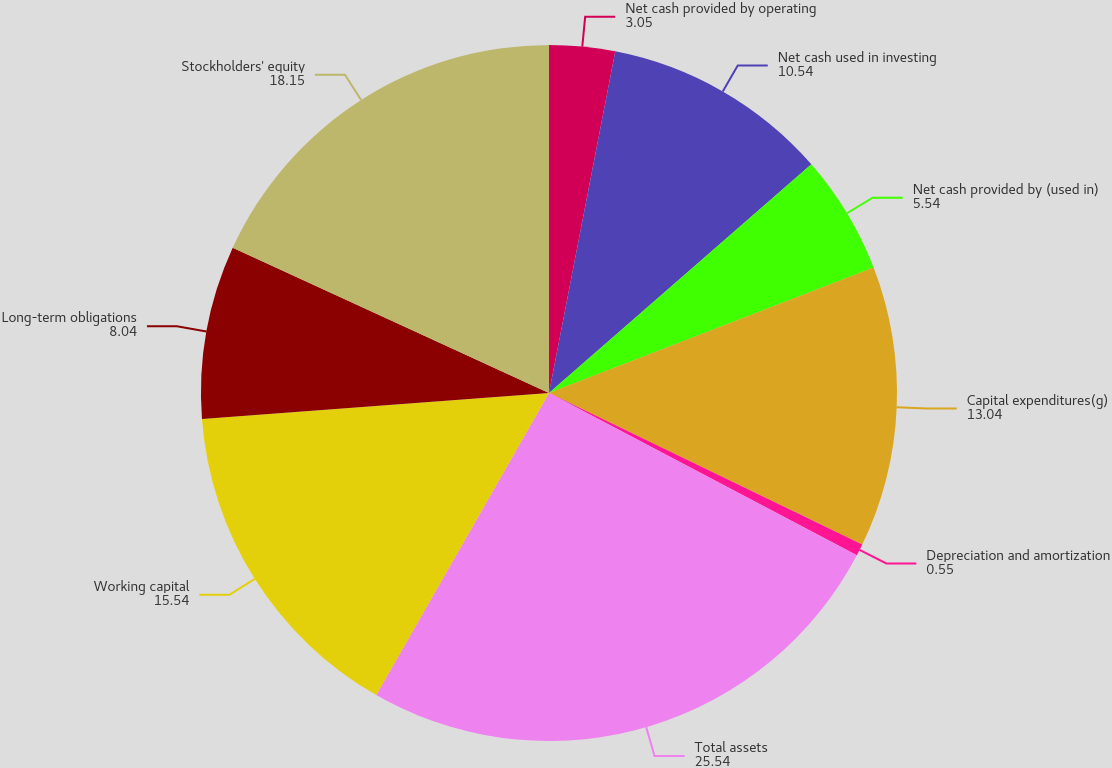Convert chart. <chart><loc_0><loc_0><loc_500><loc_500><pie_chart><fcel>Net cash provided by operating<fcel>Net cash used in investing<fcel>Net cash provided by (used in)<fcel>Capital expenditures(g)<fcel>Depreciation and amortization<fcel>Total assets<fcel>Working capital<fcel>Long-term obligations<fcel>Stockholders' equity<nl><fcel>3.05%<fcel>10.54%<fcel>5.54%<fcel>13.04%<fcel>0.55%<fcel>25.54%<fcel>15.54%<fcel>8.04%<fcel>18.15%<nl></chart> 